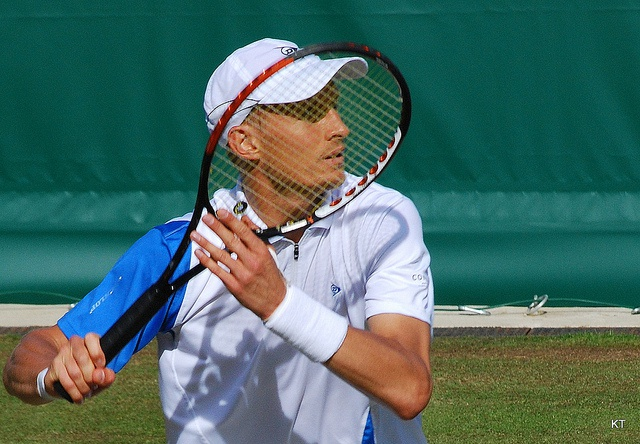Describe the objects in this image and their specific colors. I can see people in teal, lavender, brown, darkgray, and gray tones and tennis racket in teal, black, lavender, and salmon tones in this image. 